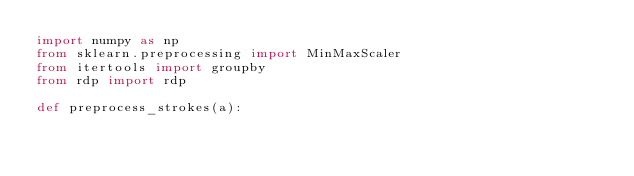<code> <loc_0><loc_0><loc_500><loc_500><_Python_>import numpy as np
from sklearn.preprocessing import MinMaxScaler
from itertools import groupby
from rdp import rdp

def preprocess_strokes(a):</code> 